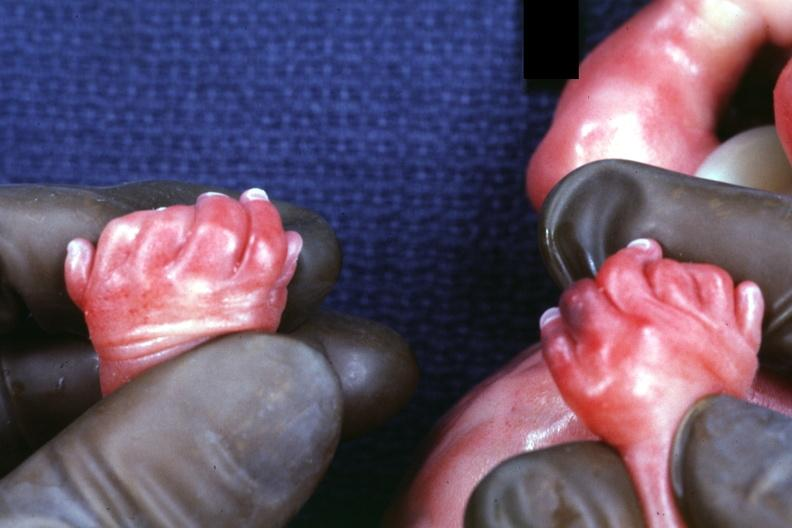does child have polycystic disease?
Answer the question using a single word or phrase. Yes 